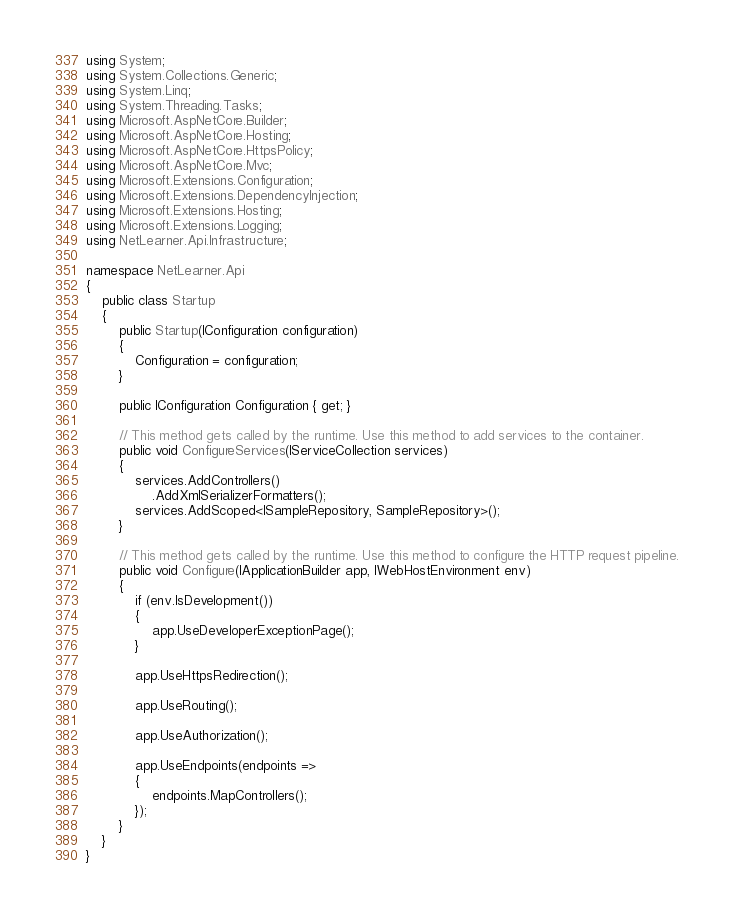<code> <loc_0><loc_0><loc_500><loc_500><_C#_>using System;
using System.Collections.Generic;
using System.Linq;
using System.Threading.Tasks;
using Microsoft.AspNetCore.Builder;
using Microsoft.AspNetCore.Hosting;
using Microsoft.AspNetCore.HttpsPolicy;
using Microsoft.AspNetCore.Mvc;
using Microsoft.Extensions.Configuration;
using Microsoft.Extensions.DependencyInjection;
using Microsoft.Extensions.Hosting;
using Microsoft.Extensions.Logging;
using NetLearner.Api.Infrastructure;

namespace NetLearner.Api
{
    public class Startup
    {
        public Startup(IConfiguration configuration)
        {
            Configuration = configuration;
        }

        public IConfiguration Configuration { get; }

        // This method gets called by the runtime. Use this method to add services to the container.
        public void ConfigureServices(IServiceCollection services)
        {
            services.AddControllers()
                .AddXmlSerializerFormatters();
            services.AddScoped<ISampleRepository, SampleRepository>();
        }

        // This method gets called by the runtime. Use this method to configure the HTTP request pipeline.
        public void Configure(IApplicationBuilder app, IWebHostEnvironment env)
        {
            if (env.IsDevelopment())
            {
                app.UseDeveloperExceptionPage();
            }

            app.UseHttpsRedirection();

            app.UseRouting();

            app.UseAuthorization();

            app.UseEndpoints(endpoints =>
            {
                endpoints.MapControllers();
            });
        }
    }
}
</code> 